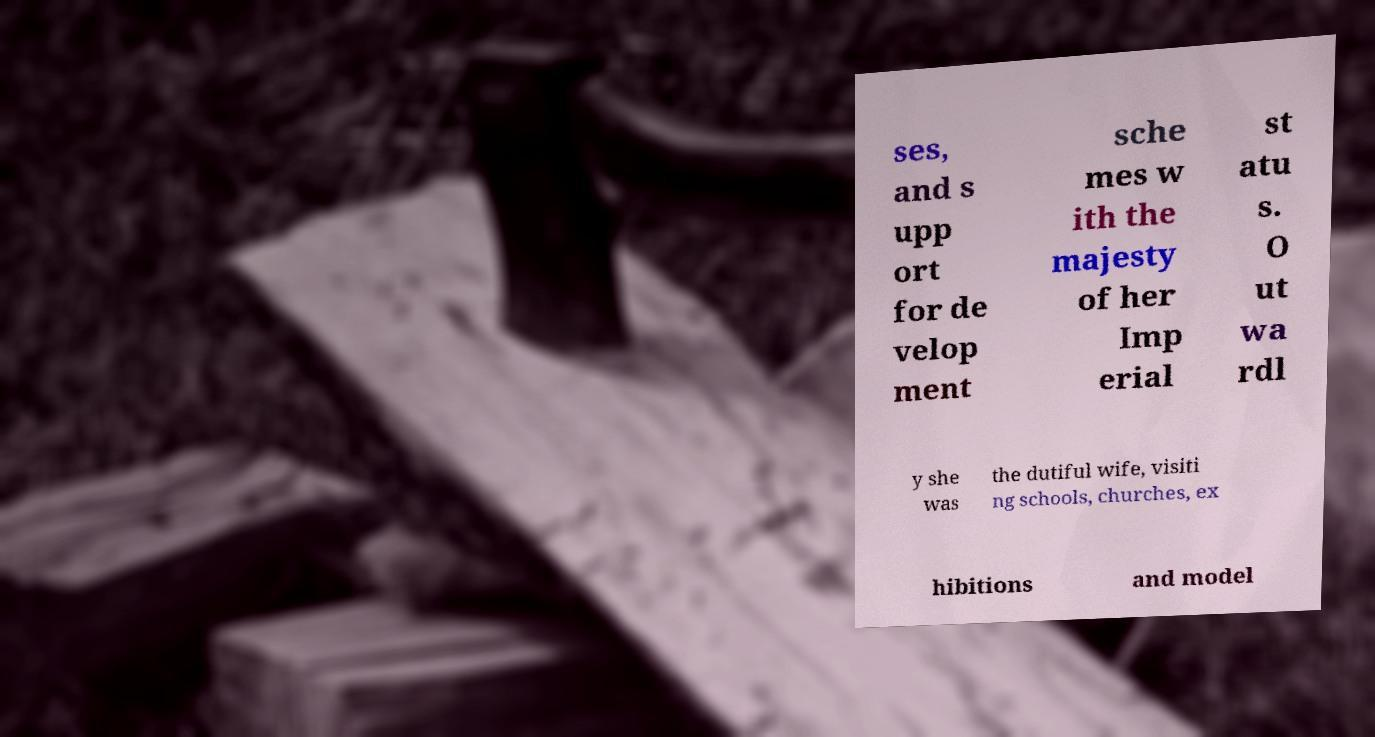Please identify and transcribe the text found in this image. ses, and s upp ort for de velop ment sche mes w ith the majesty of her Imp erial st atu s. O ut wa rdl y she was the dutiful wife, visiti ng schools, churches, ex hibitions and model 